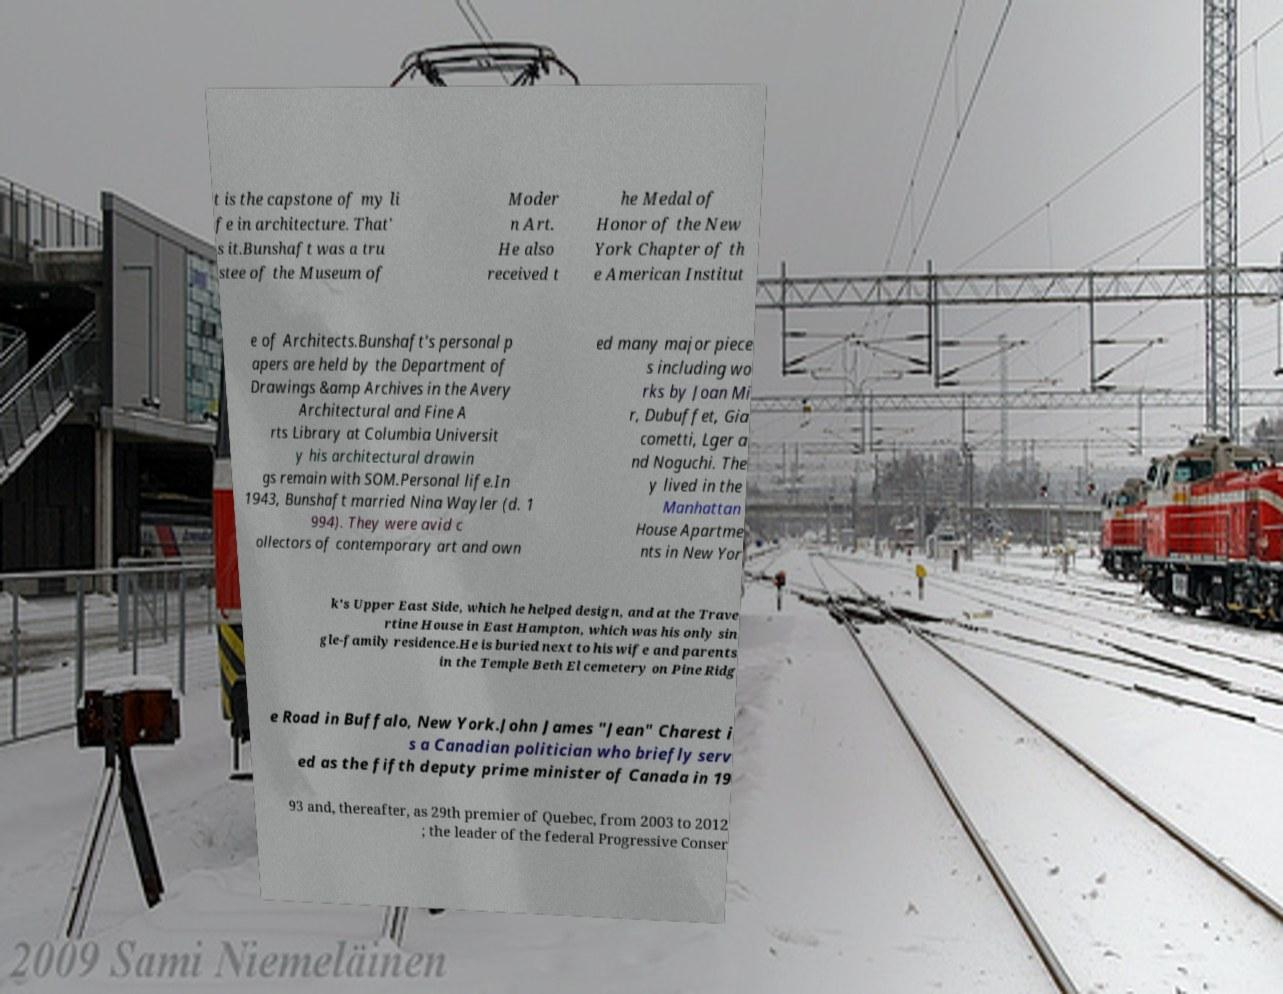Can you accurately transcribe the text from the provided image for me? t is the capstone of my li fe in architecture. That' s it.Bunshaft was a tru stee of the Museum of Moder n Art. He also received t he Medal of Honor of the New York Chapter of th e American Institut e of Architects.Bunshaft's personal p apers are held by the Department of Drawings &amp Archives in the Avery Architectural and Fine A rts Library at Columbia Universit y his architectural drawin gs remain with SOM.Personal life.In 1943, Bunshaft married Nina Wayler (d. 1 994). They were avid c ollectors of contemporary art and own ed many major piece s including wo rks by Joan Mi r, Dubuffet, Gia cometti, Lger a nd Noguchi. The y lived in the Manhattan House Apartme nts in New Yor k's Upper East Side, which he helped design, and at the Trave rtine House in East Hampton, which was his only sin gle-family residence.He is buried next to his wife and parents in the Temple Beth El cemetery on Pine Ridg e Road in Buffalo, New York.John James "Jean" Charest i s a Canadian politician who briefly serv ed as the fifth deputy prime minister of Canada in 19 93 and, thereafter, as 29th premier of Quebec, from 2003 to 2012 ; the leader of the federal Progressive Conser 